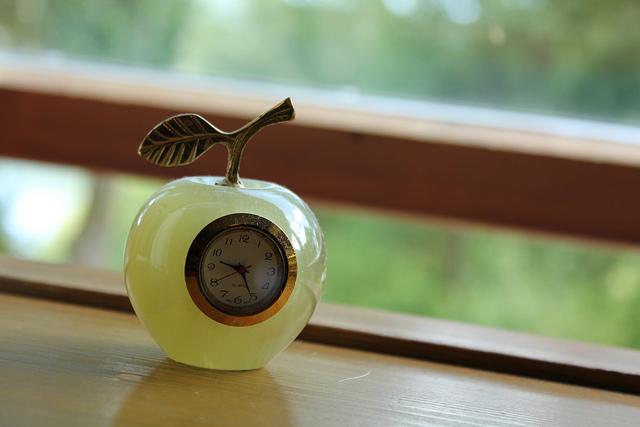What is the object on the window sill?
Keep it brief. Clock. What color is the glass apple?
Give a very brief answer. Yellow. What time is it?
Answer briefly. 9:25. Is the fruit made of glass?
Quick response, please. Yes. 